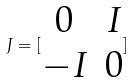<formula> <loc_0><loc_0><loc_500><loc_500>J = [ \begin{matrix} 0 & I \\ - I & 0 \end{matrix} ]</formula> 